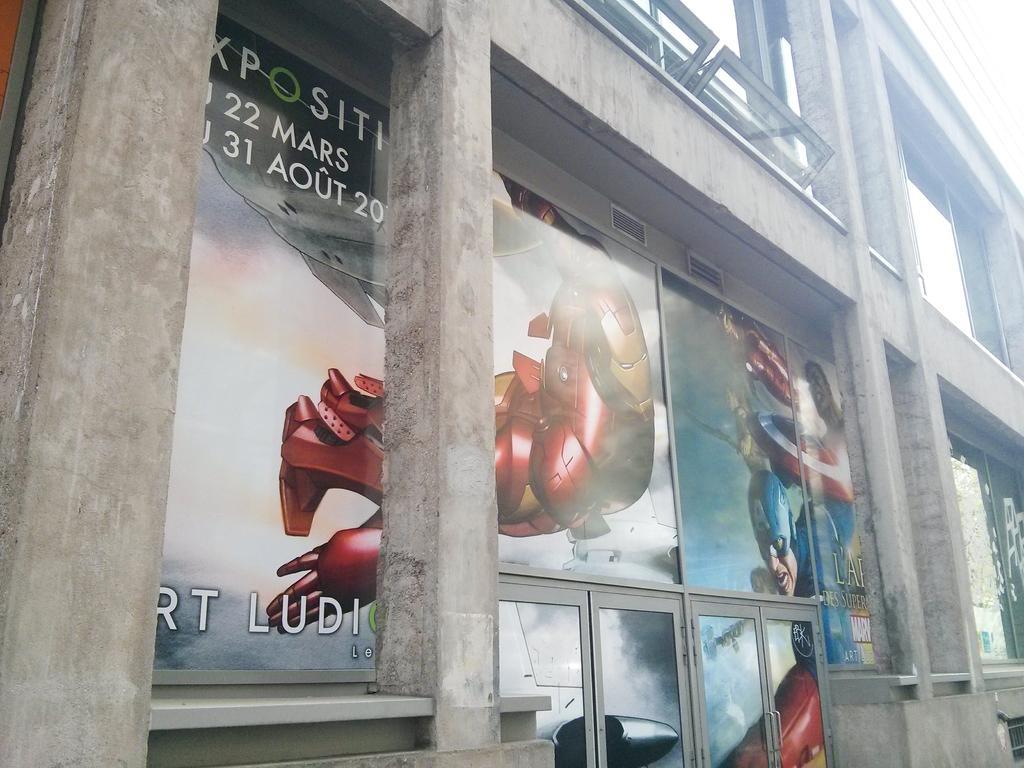Describe this image in one or two sentences. In this image there is a building with animated posters on it. 